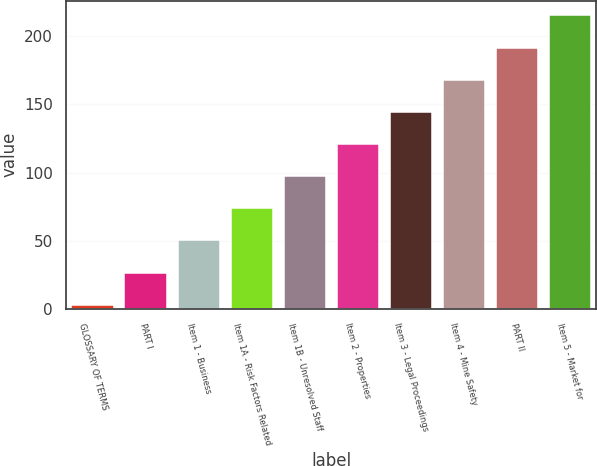<chart> <loc_0><loc_0><loc_500><loc_500><bar_chart><fcel>GLOSSARY OF TERMS<fcel>PART I<fcel>Item 1 - Business<fcel>Item 1A - Risk Factors Related<fcel>Item 1B - Unresolved Staff<fcel>Item 2 - Properties<fcel>Item 3 - Legal Proceedings<fcel>Item 4 - Mine Safety<fcel>PART II<fcel>Item 5 - Market for<nl><fcel>3<fcel>26.6<fcel>50.2<fcel>73.8<fcel>97.4<fcel>121<fcel>144.6<fcel>168.2<fcel>191.8<fcel>215.4<nl></chart> 